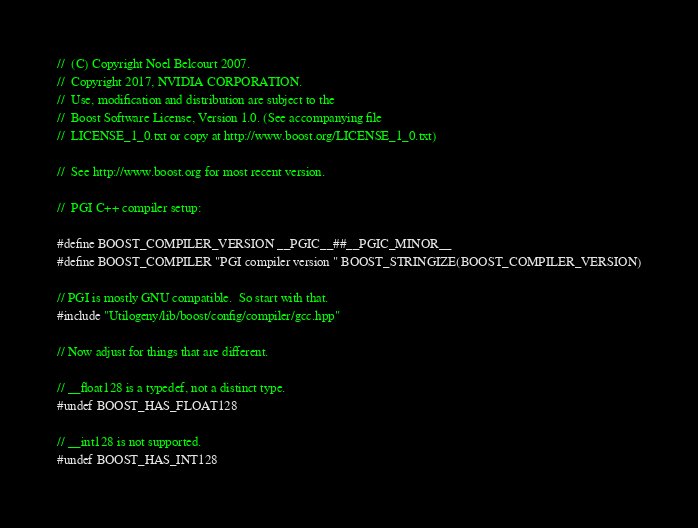Convert code to text. <code><loc_0><loc_0><loc_500><loc_500><_C++_>//  (C) Copyright Noel Belcourt 2007.
//  Copyright 2017, NVIDIA CORPORATION.
//  Use, modification and distribution are subject to the
//  Boost Software License, Version 1.0. (See accompanying file
//  LICENSE_1_0.txt or copy at http://www.boost.org/LICENSE_1_0.txt)

//  See http://www.boost.org for most recent version.

//  PGI C++ compiler setup:

#define BOOST_COMPILER_VERSION __PGIC__##__PGIC_MINOR__
#define BOOST_COMPILER "PGI compiler version " BOOST_STRINGIZE(BOOST_COMPILER_VERSION)

// PGI is mostly GNU compatible.  So start with that.
#include "Utilogeny/lib/boost/config/compiler/gcc.hpp"

// Now adjust for things that are different.

// __float128 is a typedef, not a distinct type.
#undef BOOST_HAS_FLOAT128

// __int128 is not supported.
#undef BOOST_HAS_INT128
</code> 